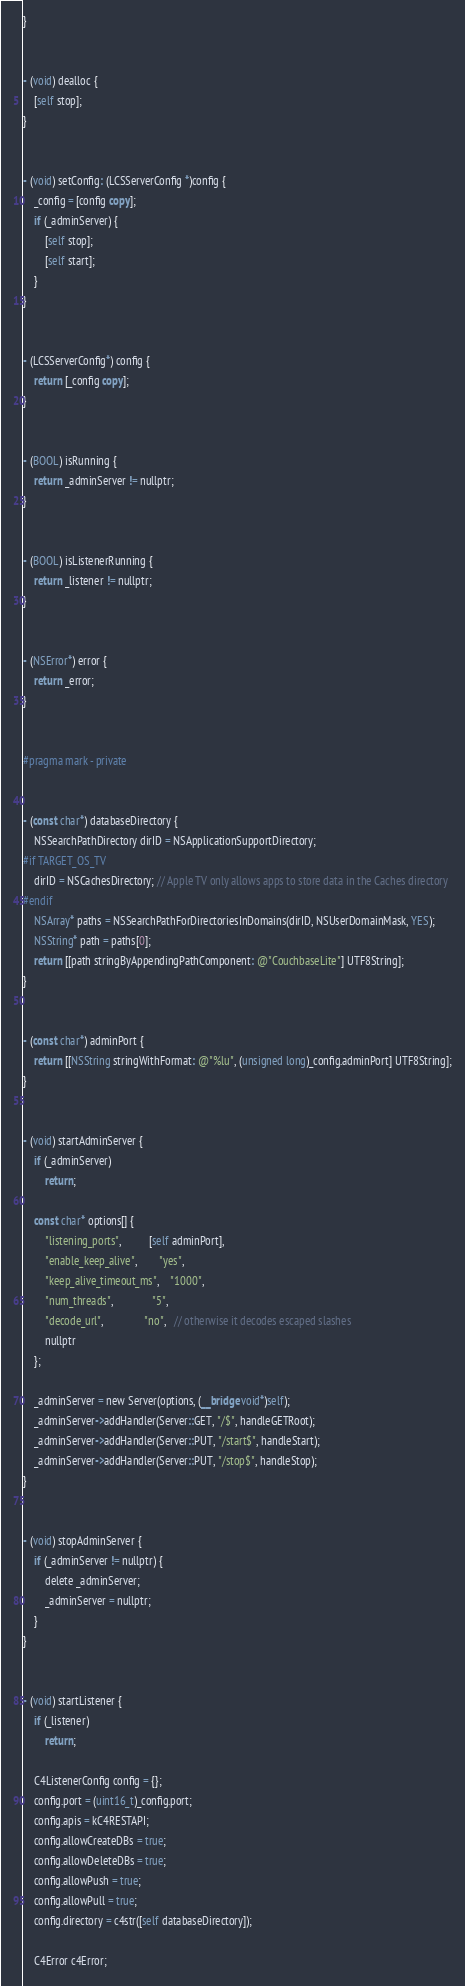Convert code to text. <code><loc_0><loc_0><loc_500><loc_500><_ObjectiveC_>}


- (void) dealloc {
    [self stop];
}


- (void) setConfig: (LCSServerConfig *)config {
    _config = [config copy];
    if (_adminServer) {
        [self stop];
        [self start];
    }
}


- (LCSServerConfig*) config {
    return [_config copy];
}


- (BOOL) isRunning {
    return _adminServer != nullptr;
}


- (BOOL) isListenerRunning {
    return _listener != nullptr;
}


- (NSError*) error {
    return _error;
}


#pragma mark - private


- (const char*) databaseDirectory {
    NSSearchPathDirectory dirID = NSApplicationSupportDirectory;
#if TARGET_OS_TV
    dirID = NSCachesDirectory; // Apple TV only allows apps to store data in the Caches directory
#endif
    NSArray* paths = NSSearchPathForDirectoriesInDomains(dirID, NSUserDomainMask, YES);
    NSString* path = paths[0];
    return [[path stringByAppendingPathComponent: @"CouchbaseLite"] UTF8String];
}


- (const char*) adminPort {
    return [[NSString stringWithFormat: @"%lu", (unsigned long)_config.adminPort] UTF8String];
}


- (void) startAdminServer {
    if (_adminServer)
        return;
    
    const char* options[] {
        "listening_ports",          [self adminPort],
        "enable_keep_alive",        "yes",
        "keep_alive_timeout_ms",    "1000",
        "num_threads",              "5",
        "decode_url",               "no",   // otherwise it decodes escaped slashes
        nullptr
    };
    
    _adminServer = new Server(options, (__bridge void*)self);
    _adminServer->addHandler(Server::GET, "/$", handleGETRoot);
    _adminServer->addHandler(Server::PUT, "/start$", handleStart);
    _adminServer->addHandler(Server::PUT, "/stop$", handleStop);
}


- (void) stopAdminServer {
    if (_adminServer != nullptr) {
        delete _adminServer;
        _adminServer = nullptr;
    }
}


- (void) startListener {
    if (_listener)
        return;
    
    C4ListenerConfig config = {};
    config.port = (uint16_t)_config.port;
    config.apis = kC4RESTAPI;
    config.allowCreateDBs = true;
    config.allowDeleteDBs = true;
    config.allowPush = true;
    config.allowPull = true;
    config.directory = c4str([self databaseDirectory]);
    
    C4Error c4Error;</code> 